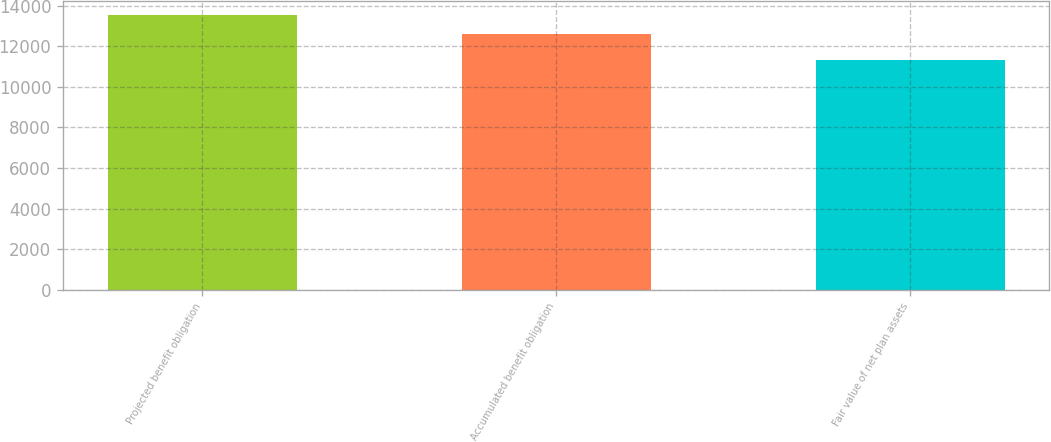Convert chart to OTSL. <chart><loc_0><loc_0><loc_500><loc_500><bar_chart><fcel>Projected benefit obligation<fcel>Accumulated benefit obligation<fcel>Fair value of net plan assets<nl><fcel>13538<fcel>12616<fcel>11302<nl></chart> 